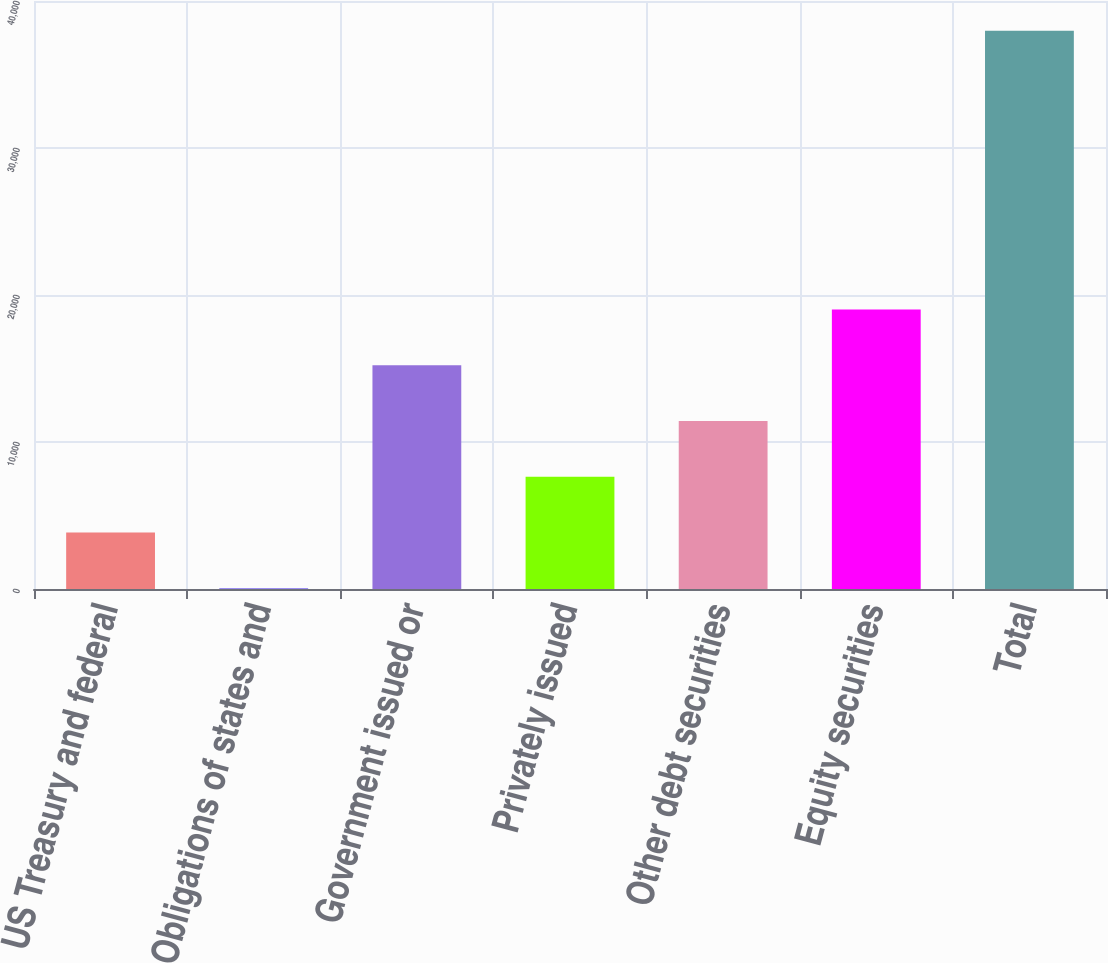<chart> <loc_0><loc_0><loc_500><loc_500><bar_chart><fcel>US Treasury and federal<fcel>Obligations of states and<fcel>Government issued or<fcel>Privately issued<fcel>Other debt securities<fcel>Equity securities<fcel>Total<nl><fcel>3838.8<fcel>45<fcel>15220.2<fcel>7632.6<fcel>11426.4<fcel>19014<fcel>37983<nl></chart> 